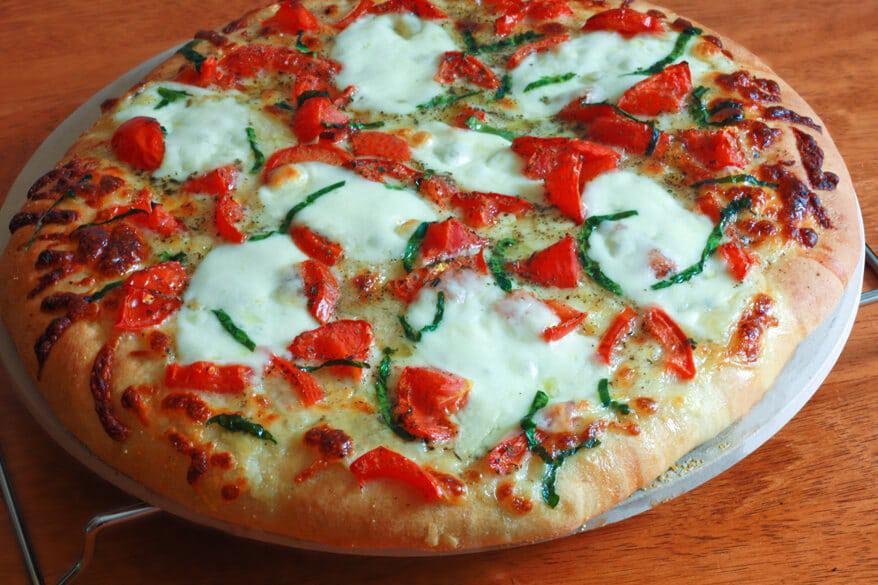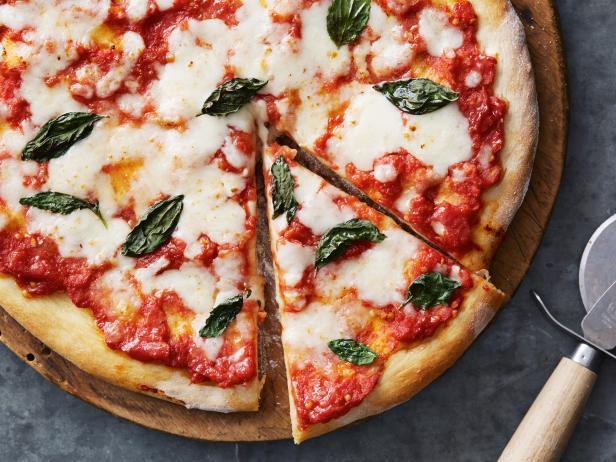The first image is the image on the left, the second image is the image on the right. Given the left and right images, does the statement "There are two circle pizzas each on a plate or pan." hold true? Answer yes or no. Yes. The first image is the image on the left, the second image is the image on the right. Given the left and right images, does the statement "There is an uncut pizza in the right image." hold true? Answer yes or no. No. 